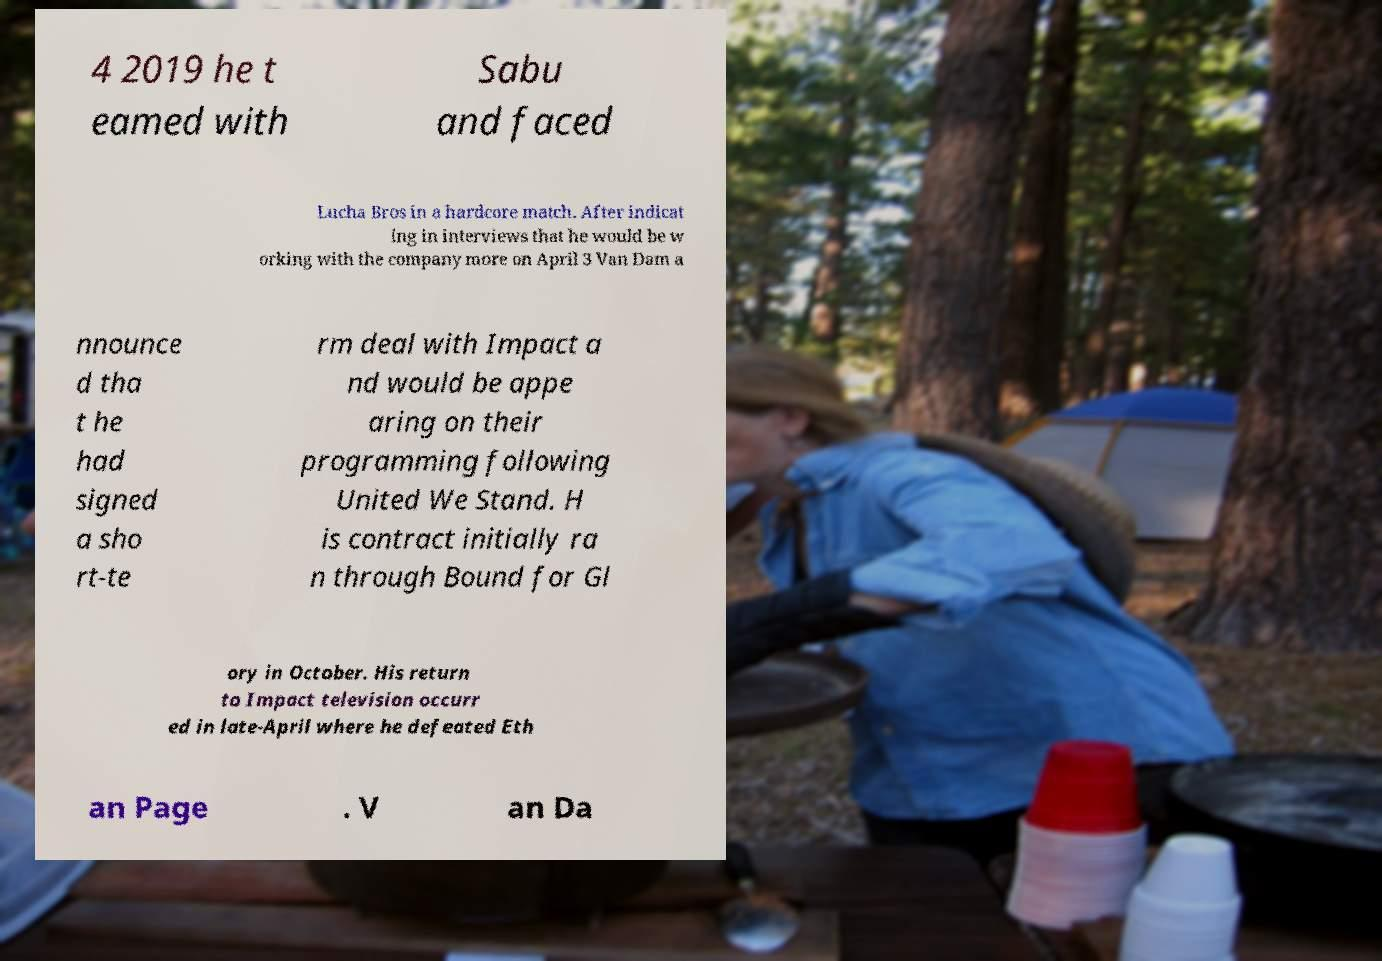I need the written content from this picture converted into text. Can you do that? 4 2019 he t eamed with Sabu and faced Lucha Bros in a hardcore match. After indicat ing in interviews that he would be w orking with the company more on April 3 Van Dam a nnounce d tha t he had signed a sho rt-te rm deal with Impact a nd would be appe aring on their programming following United We Stand. H is contract initially ra n through Bound for Gl ory in October. His return to Impact television occurr ed in late-April where he defeated Eth an Page . V an Da 